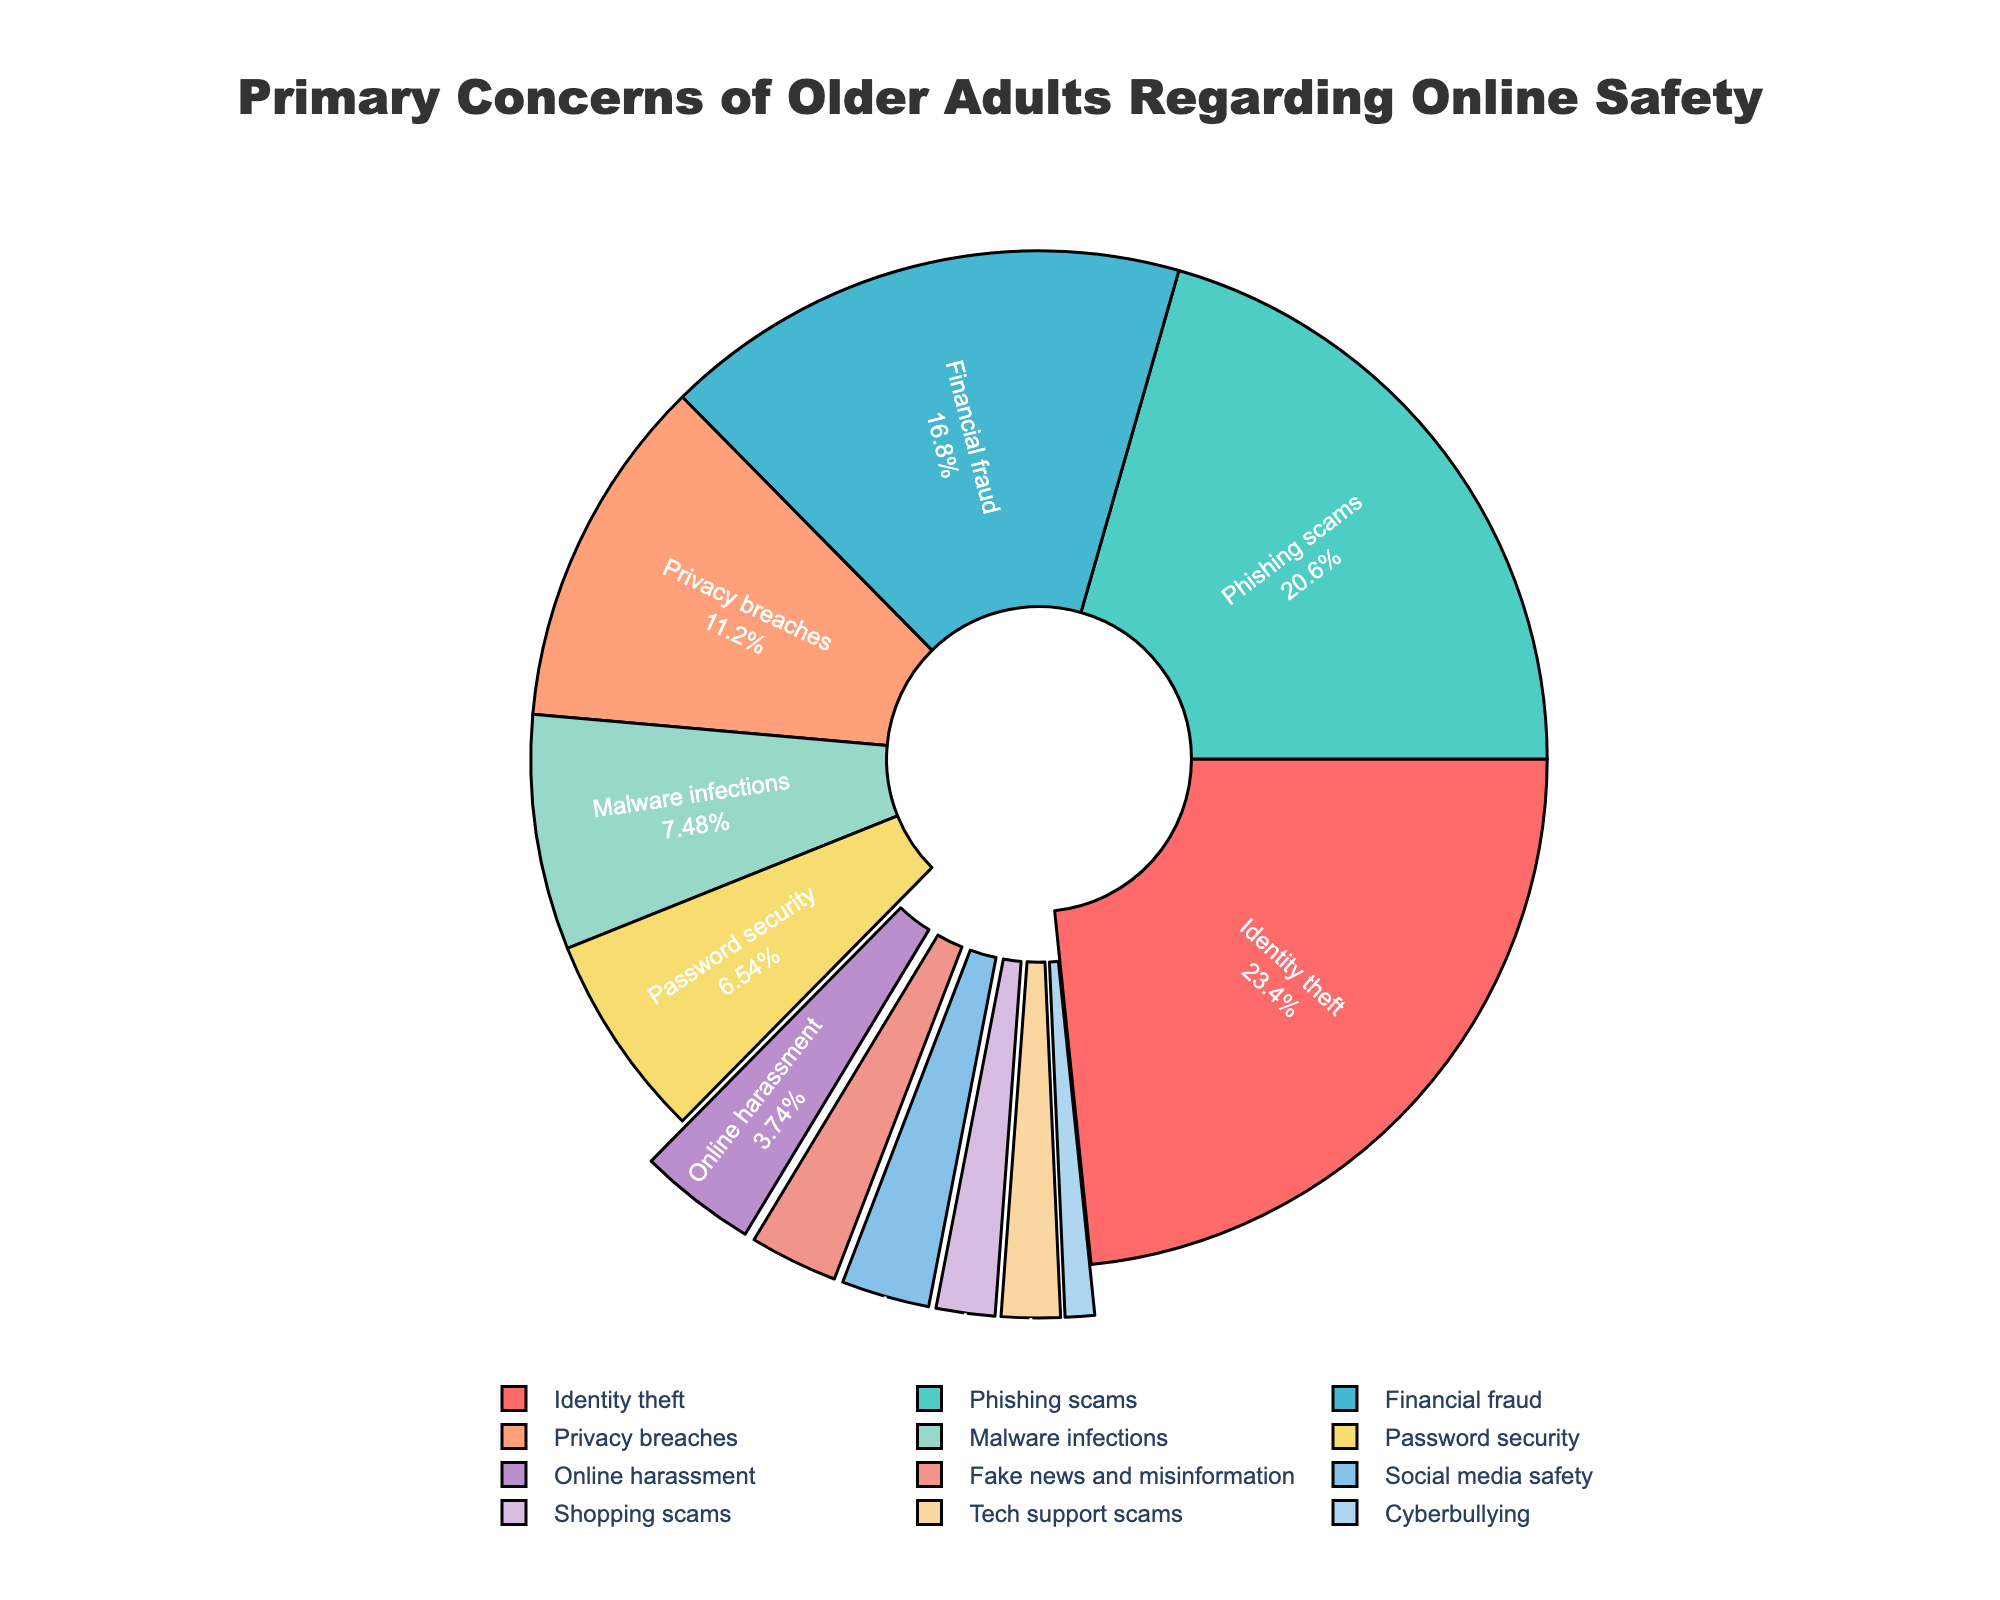What percentage of older adults are concerned about phishing scams? The "Phishing scams" slice in the pie chart is labeled with its percentage, which is 22%.
Answer: 22% Which concern has a higher percentage: online harassment or financial fraud? The "Financial fraud" slice is larger and labeled 18%, while the "Online harassment" slice is smaller and labeled 4%. Thus, financial fraud has a higher percentage.
Answer: Financial fraud What is the combined percentage of concerns related to phishing scams and privacy breaches? The percentages for "Phishing scams" and "Privacy breaches" are 22% and 12%, respectively. Adding these together: 22% + 12% = 34%.
Answer: 34% Are there more older adults concerned with malware infections or social media safety? The "Malware infections" slice is labeled 8%, and the "Social media safety" slice is labeled 3%. Therefore, more older adults are concerned with malware infections.
Answer: Malware infections How many categories have a percentage of 5% or below? The slices labeled "Social media safety," "Shopping scams," "Tech support scams," "Cyberbullying," and "Online harassment" have percentages of 5% or below. Counting these categories: 1 (Online harassment) + 1 (Social media safety) + 1 (Shopping scams) + 1 (Tech support scams) + 1 (Cyberbullying) = 5 categories.
Answer: 5 What is the difference in percentage between identity theft and password security concerns? The percentage for "Identity theft" is 25%, and for "Password security" it is 7%. The difference is: 25% - 7% = 18%.
Answer: 18% Which concern has the smallest percentage, and what is its value? Looking at the smallest slice, "Cyberbullying" has the smallest percentage, labeled as 1%.
Answer: Cyberbullying, 1% What is the combined percentage of the three largest concerns? The three largest slices are "Identity theft" (25%), "Phishing scams" (22%), and "Financial fraud" (18%). Adding these together: 25% + 22% + 18% = 65%.
Answer: 65% Are password security and privacy breaches combined a larger concern than phishing scams alone? Combining "Password security" (7%) and "Privacy breaches" (12%) results in 7% + 12% = 19%. "Phishing scams" alone is 22%. Therefore, they combined are not larger than phishing scams alone.
Answer: No 